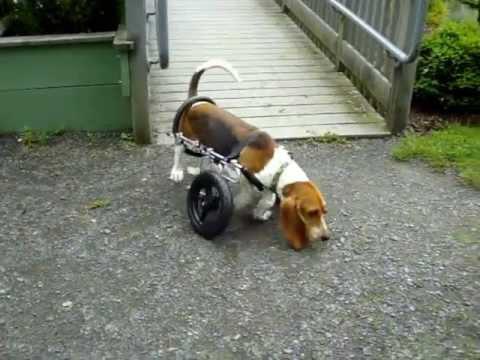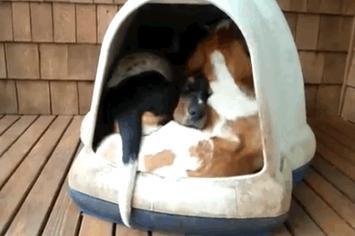The first image is the image on the left, the second image is the image on the right. Analyze the images presented: Is the assertion "The dog in the left image is looking towards the camera." valid? Answer yes or no. No. The first image is the image on the left, the second image is the image on the right. Assess this claim about the two images: "An image shows a basset hound wearing a front foot prosthetic.". Correct or not? Answer yes or no. No. 